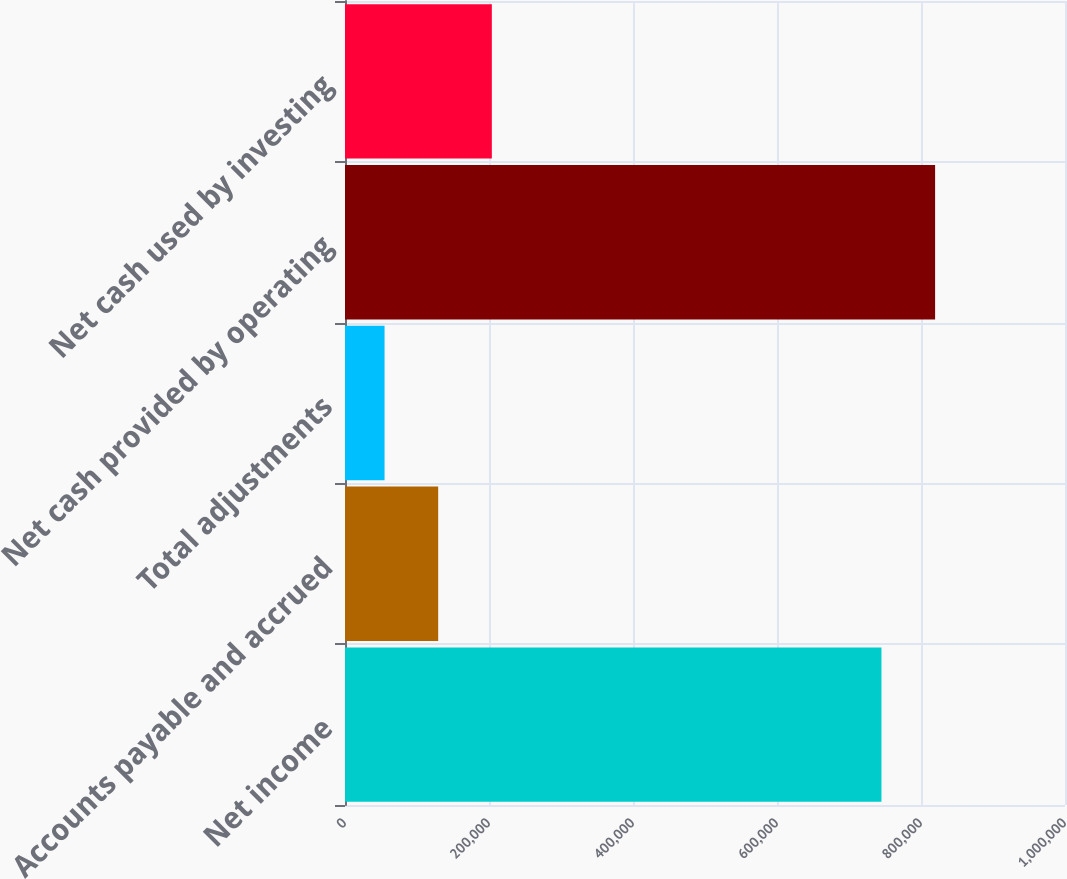Convert chart to OTSL. <chart><loc_0><loc_0><loc_500><loc_500><bar_chart><fcel>Net income<fcel>Accounts payable and accrued<fcel>Total adjustments<fcel>Net cash provided by operating<fcel>Net cash used by investing<nl><fcel>745077<fcel>129432<fcel>54924<fcel>819585<fcel>203939<nl></chart> 